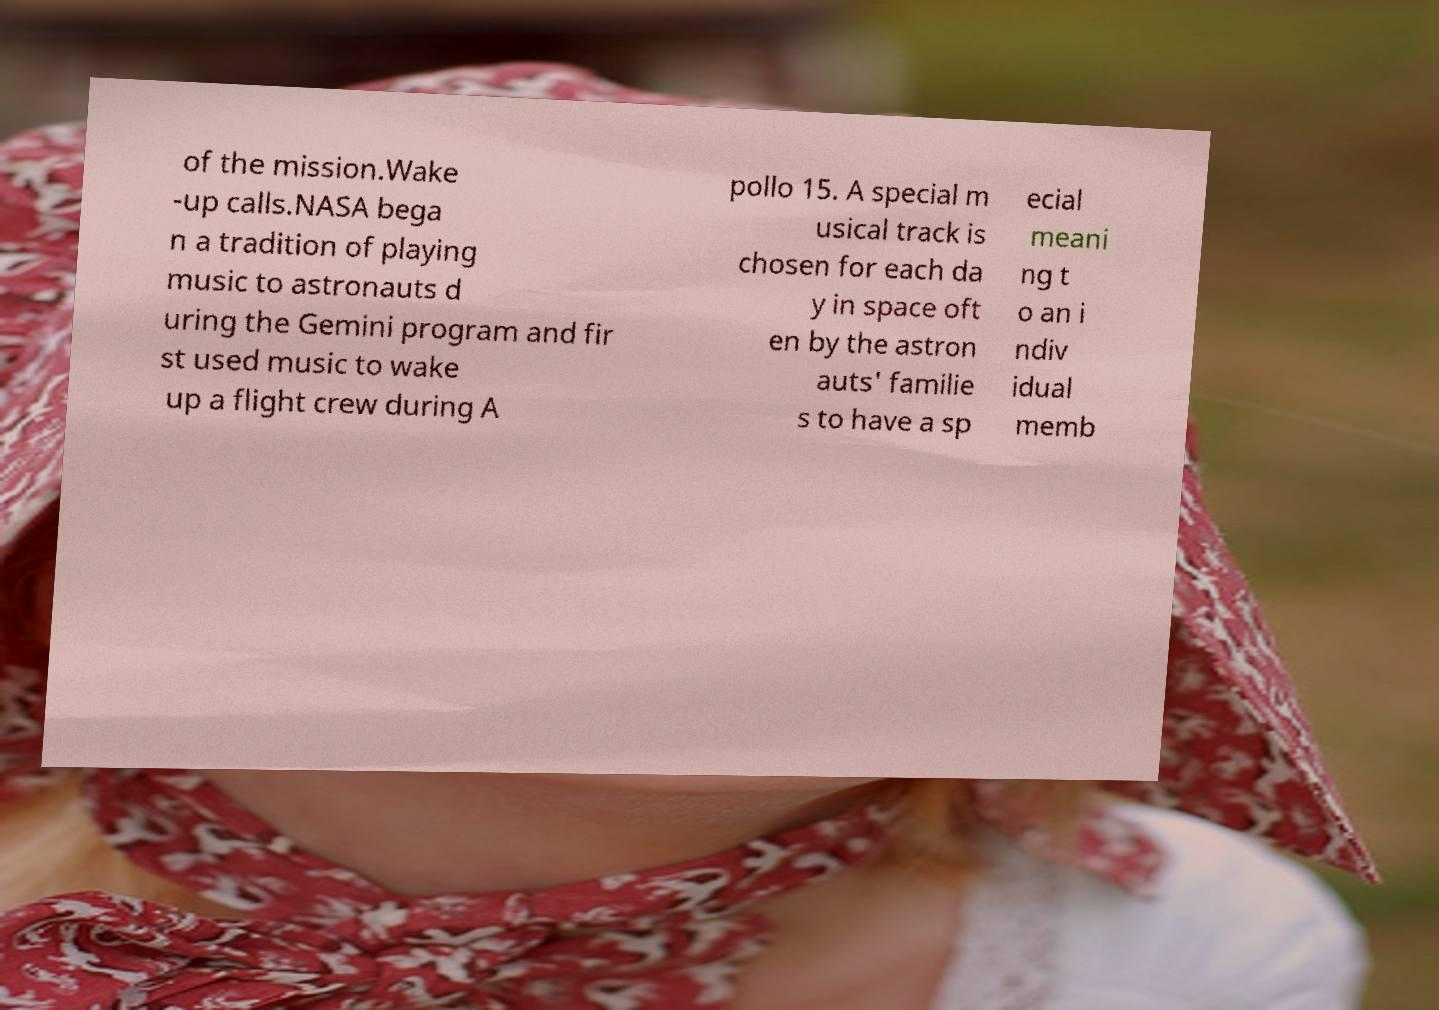For documentation purposes, I need the text within this image transcribed. Could you provide that? of the mission.Wake -up calls.NASA bega n a tradition of playing music to astronauts d uring the Gemini program and fir st used music to wake up a flight crew during A pollo 15. A special m usical track is chosen for each da y in space oft en by the astron auts' familie s to have a sp ecial meani ng t o an i ndiv idual memb 